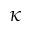<formula> <loc_0><loc_0><loc_500><loc_500>\kappa</formula> 